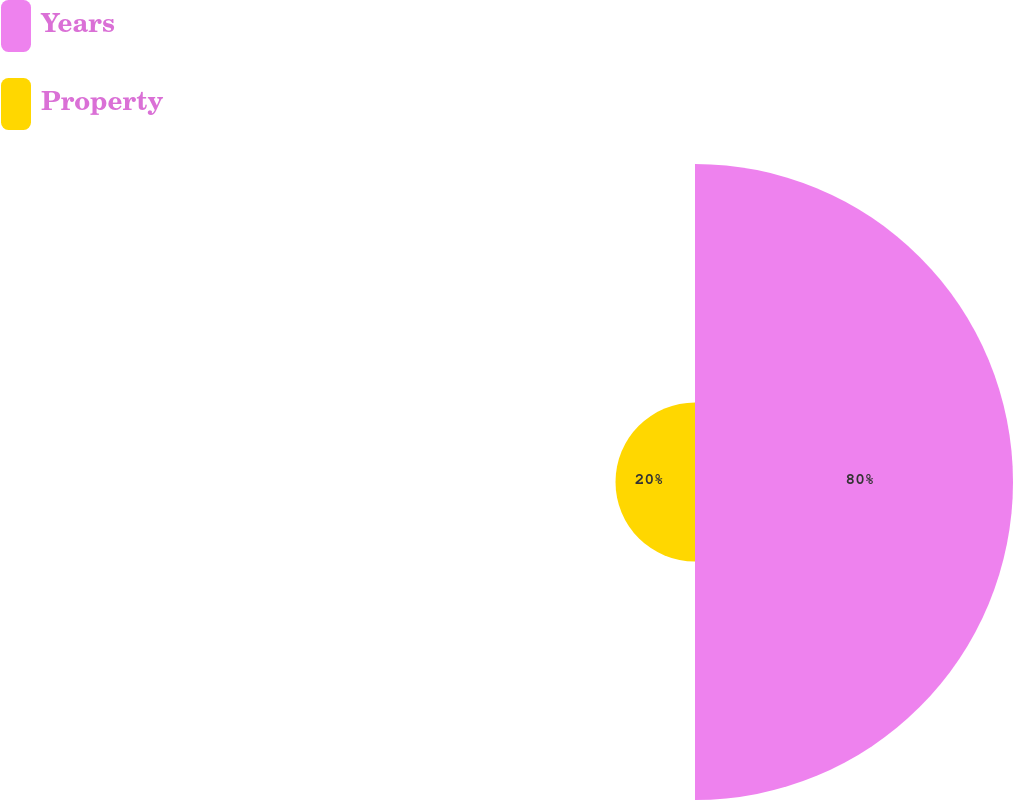Convert chart to OTSL. <chart><loc_0><loc_0><loc_500><loc_500><pie_chart><fcel>Years<fcel>Property<nl><fcel>80.0%<fcel>20.0%<nl></chart> 